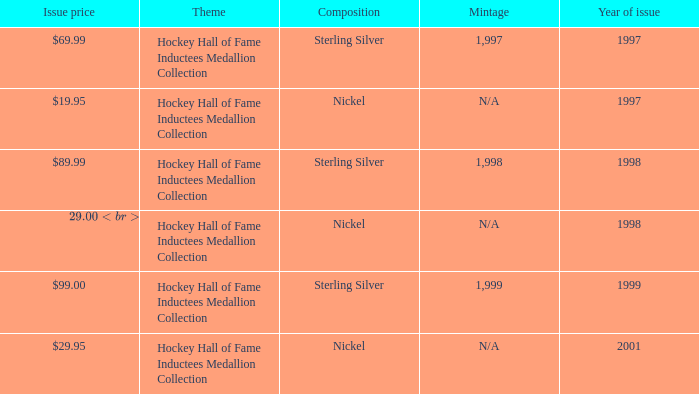Which composition has an issue price of $99.00? Sterling Silver. 